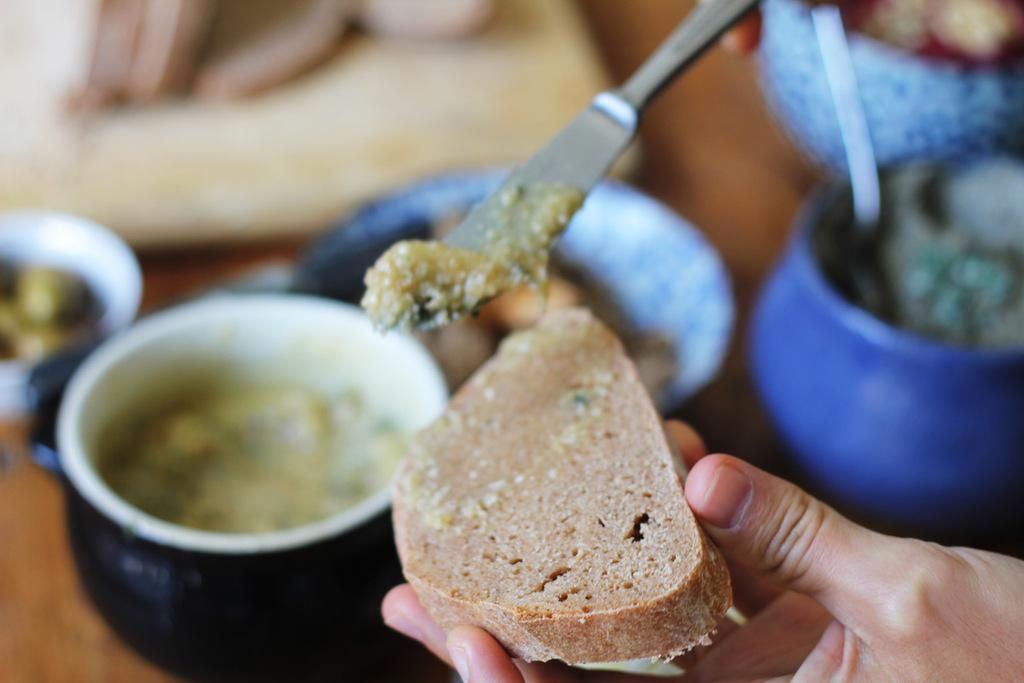How many people are in the image? There are persons in the image, but the exact number is not specified. What is one person holding in the image? One person is holding a bread and spoon in the image. What is present on the table in the image? There is a table in the image, and there are bowls on the table. What can be found inside the bowls on the table? There are food items in the bowls on the table. Can you tell me how many matches are on the table in the image? There is no mention of matches in the image, so we cannot determine their presence or quantity. 